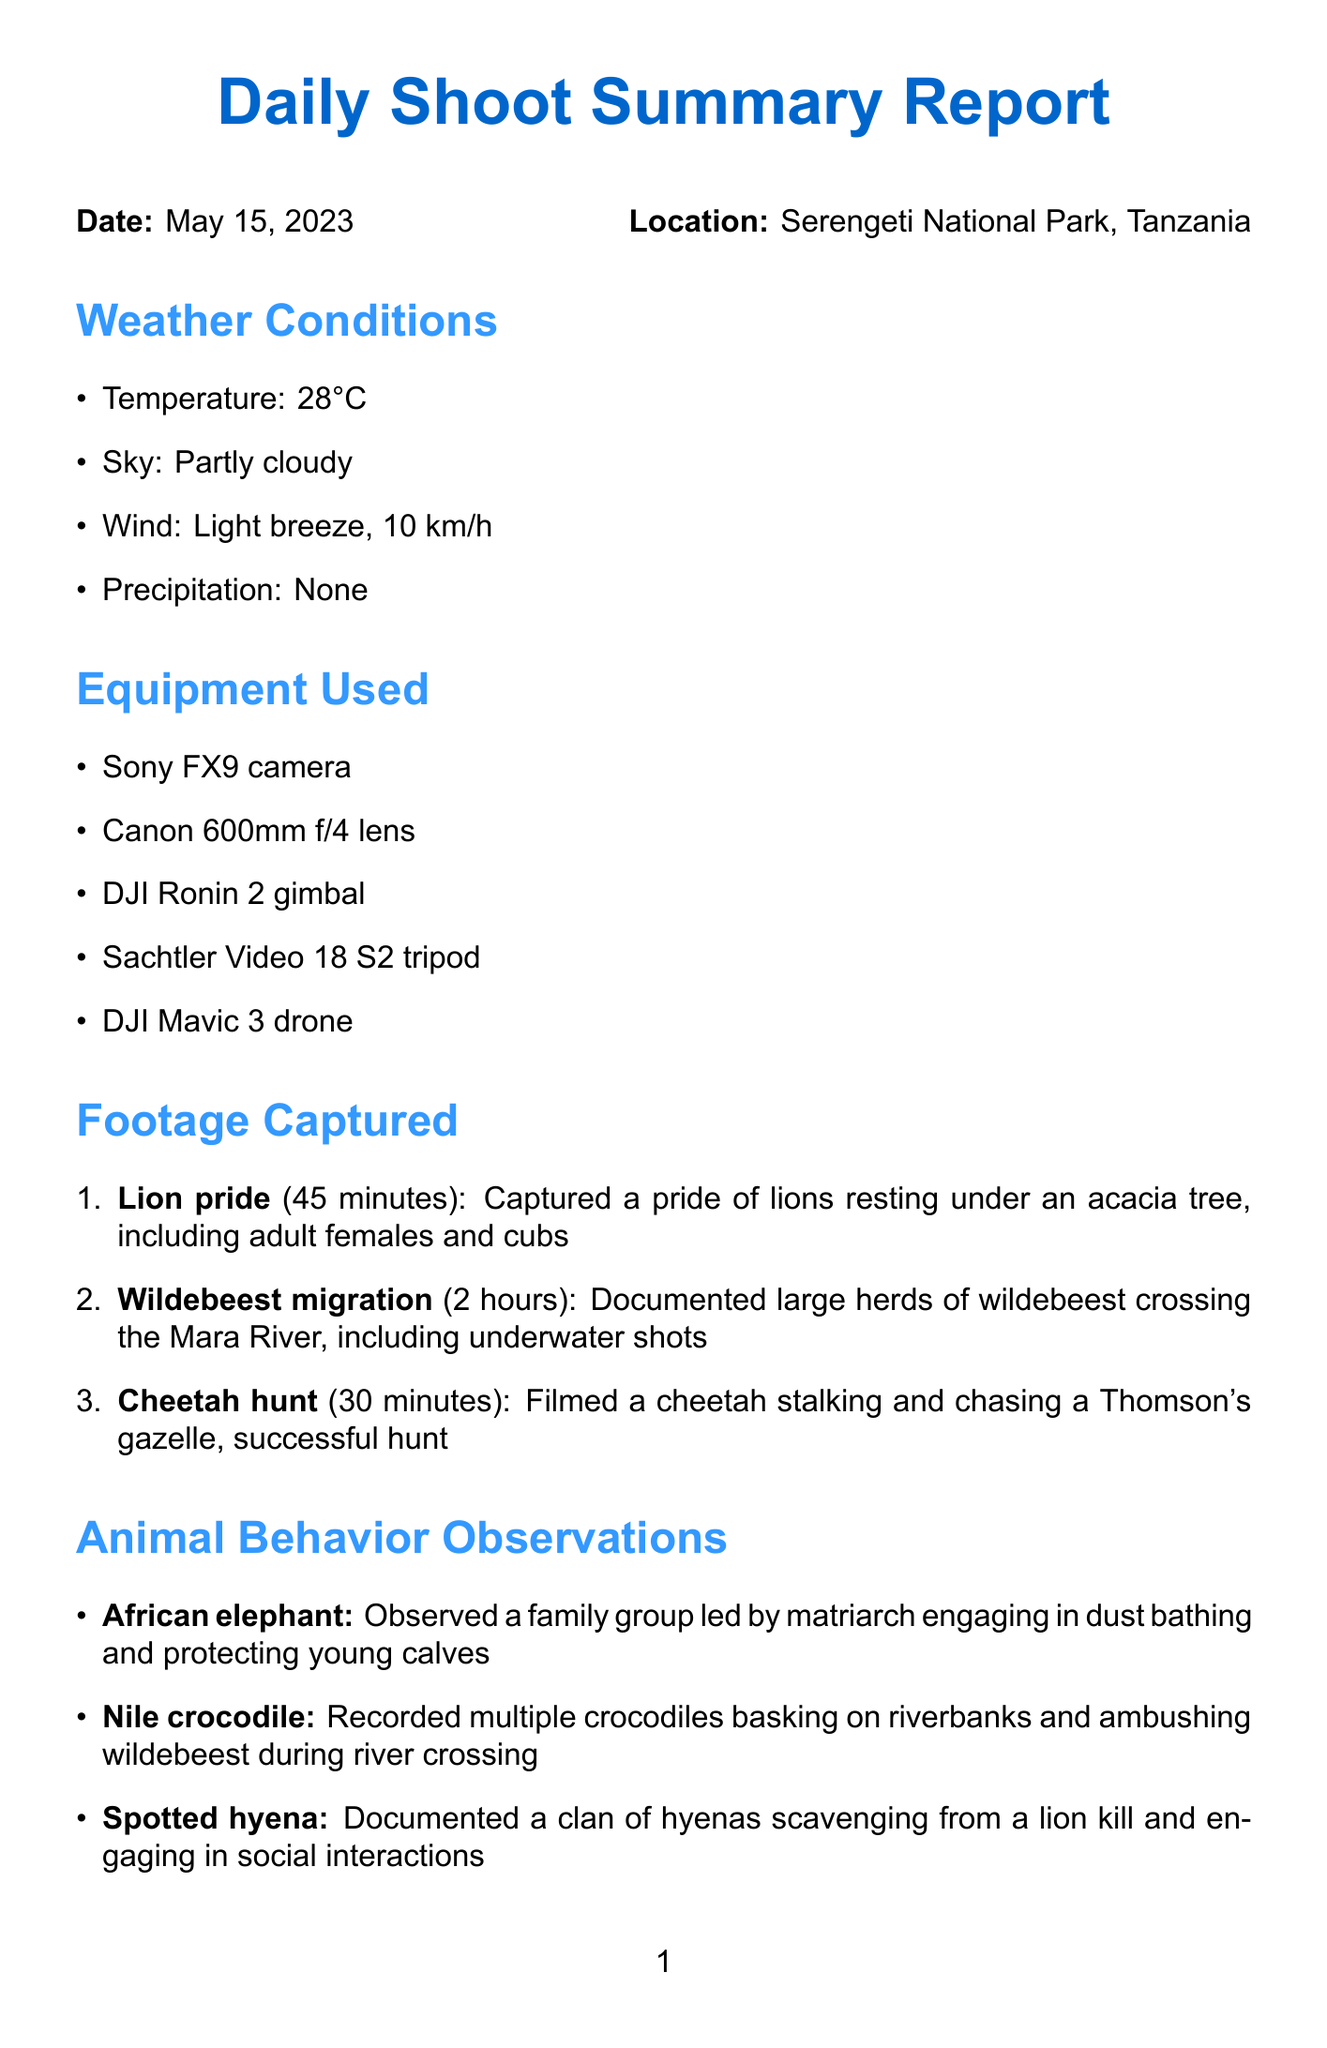What was the shoot date? The shoot date is mentioned clearly at the top of the report under the date section.
Answer: May 15, 2023 What location was the shoot conducted in? The location is specified prominently in the report, indicating where the action took place.
Answer: Serengeti National Park, Tanzania How many team members were involved? The number of team members can be counted from the team members section in the document.
Answer: 4 What animal species was observed during the shoot? The document lists various animal behaviors observed during the day, revealing different species seen.
Answer: African elephant How long was the footage captured of the wildebeest migration? The duration for this specific footage can be found in the list of footage captured.
Answer: 2 hours What challenges were encountered during the shoot? The challenges faced are outlined in a specific section of the document, detailing issues experienced.
Answer: Limited visibility during early morning due to fog What special equipment will be used the next day? The next day's plan mentions special equipment necessary for specific filming tasks.
Answer: Underwater housing for flamingo shots in Lake Magadi What was the weather condition in terms of temperature? The weather conditions section provides specific data regarding temperature during the shoot day.
Answer: 28°C What notable event occurred during the shoot? The noteworthy events section highlights significant incidents captured during filming.
Answer: Witnessed and captured rare footage of a leopard killing a python 